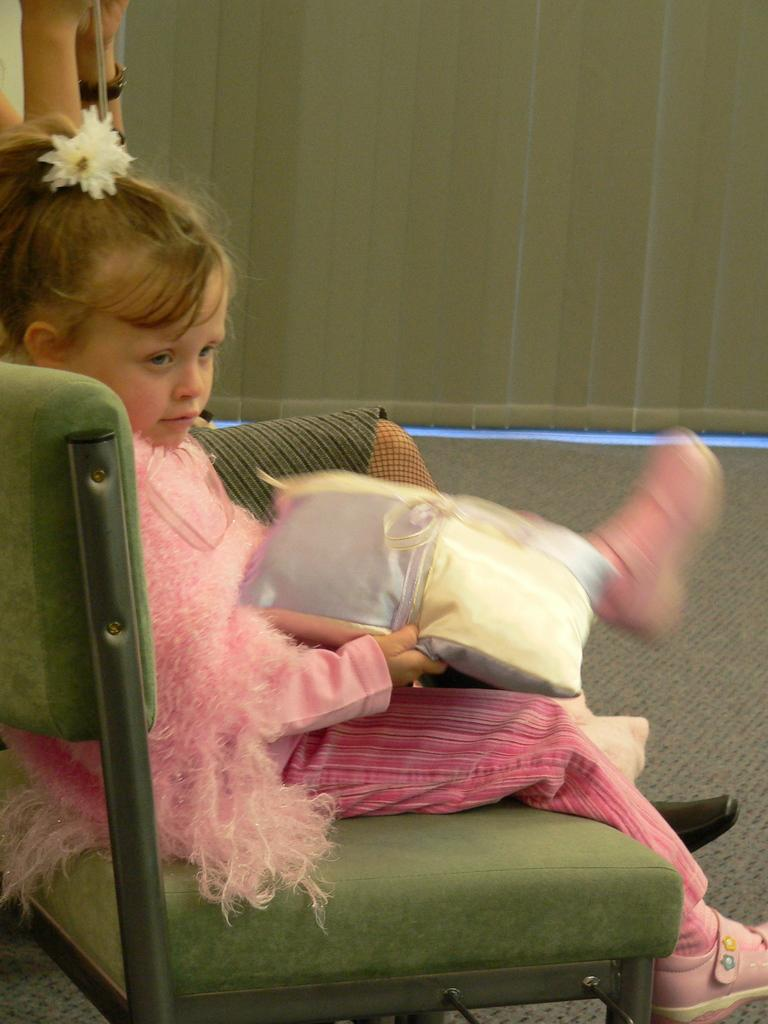Who is the main subject in the image? There is a girl in the image. What is the girl sitting on? The girl is sitting on a green chair. What is the girl wearing? The girl is wearing a pink dress. What is the girl holding in the image? The girl is holding a pillow. What color is the wall behind the girl? The background of the image is a green wall. What type of clocks can be seen hanging on the wall in the image? There are no clocks visible in the image; the background is a green wall. Is there a bat flying around the girl in the image? There is no bat present in the image. 